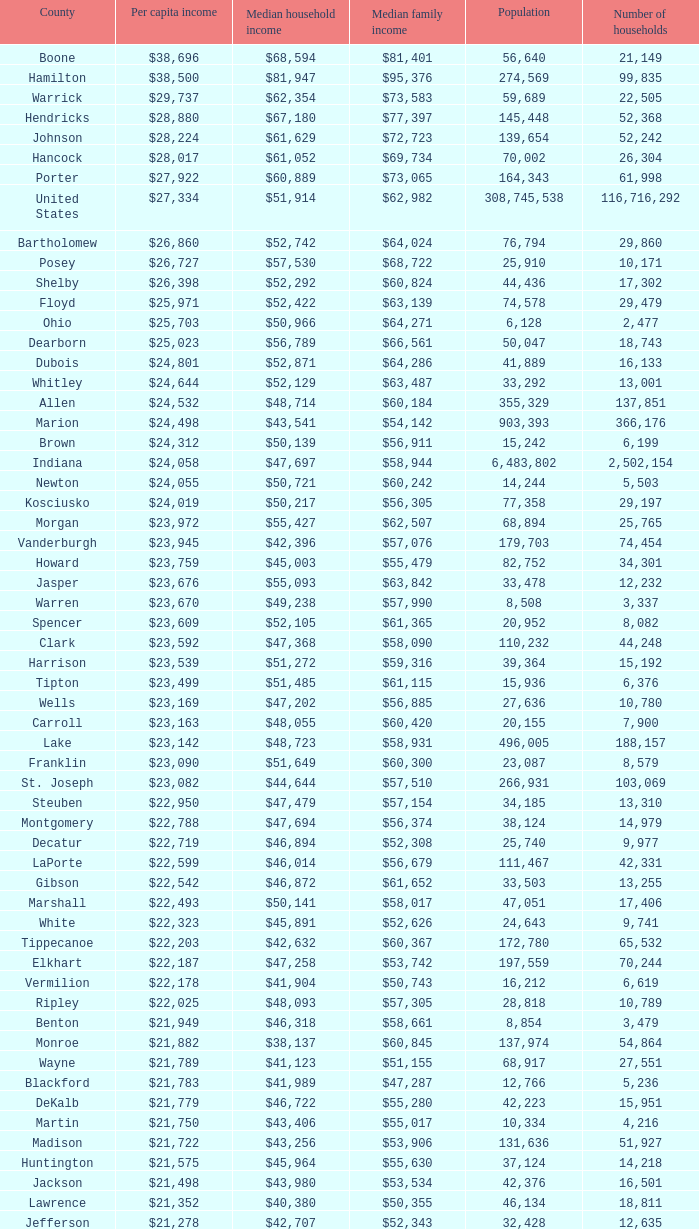If the median household income stands at $38,137, what is the median income for families? $60,845. 